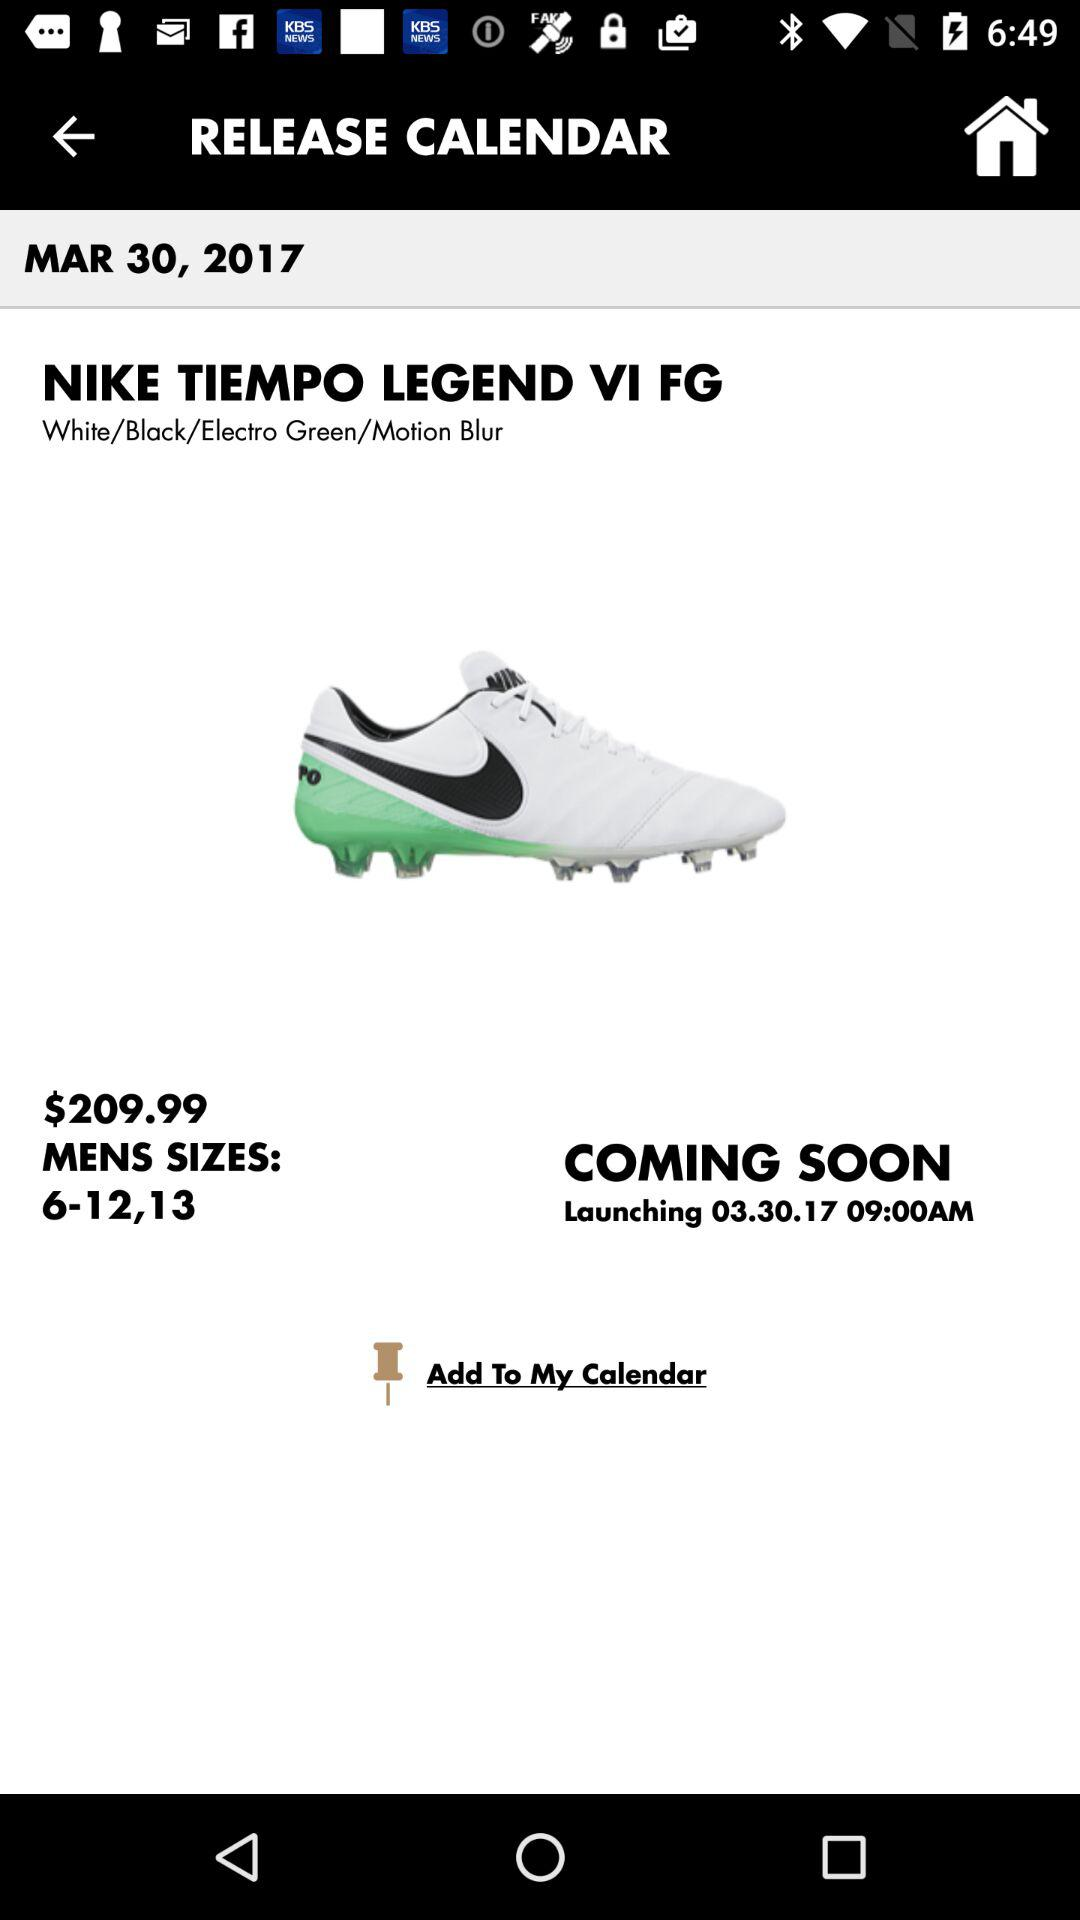What is the price of the Nike Tiempo Legend VI FG?
Answer the question using a single word or phrase. $209.99 